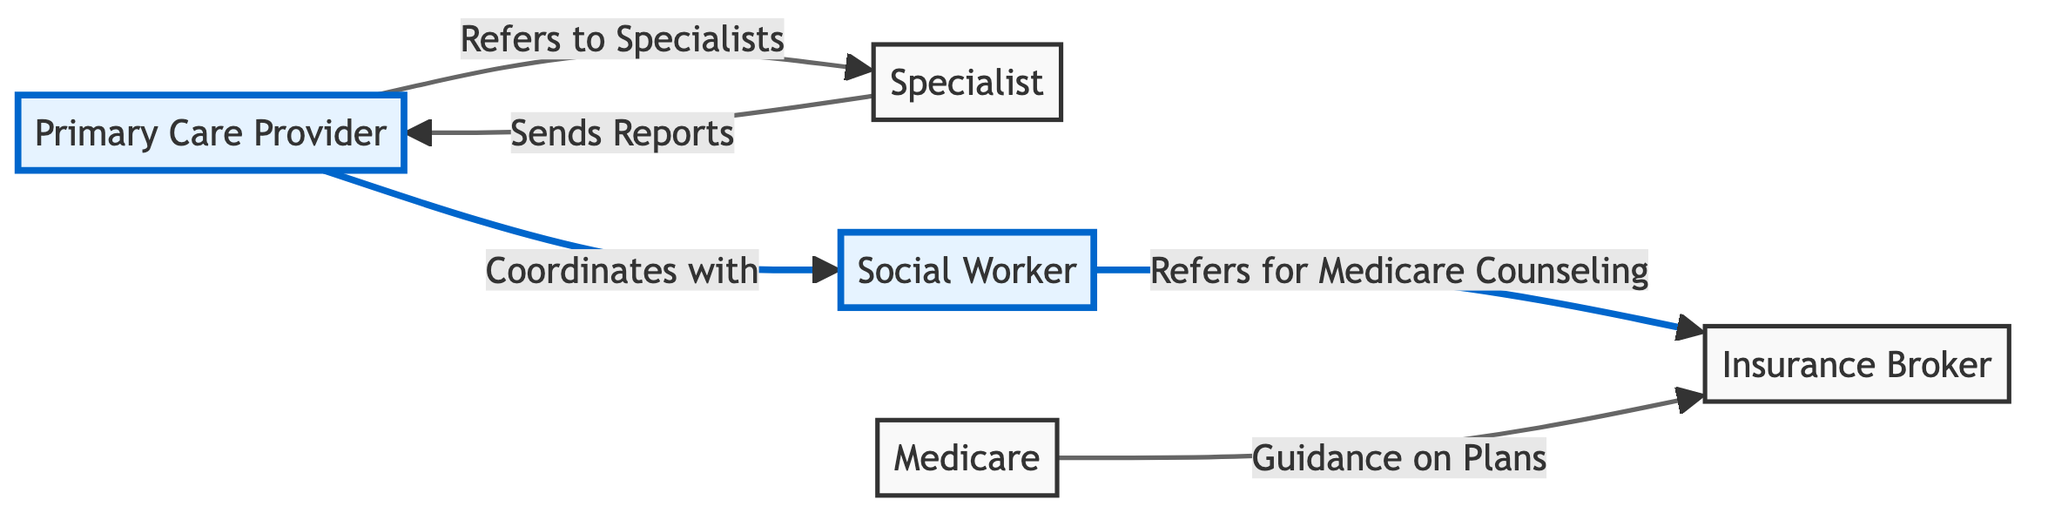What is the primary role of the Primary Care Provider? The diagram indicates that the Primary Care Provider is responsible for ensuring overall health and coordination for seniors. This includes being the main healthcare provider.
Answer: Main healthcare provider How many edges are there in the diagram? By counting the connections (arrows) between the nodes in the diagram, there are a total of five edges that illustrate the relationships among the various roles.
Answer: 5 Who does the Social Worker refer to for Medicare Counseling? The diagram shows a direct relationship where the Social Worker refers seniors to the Insurance Broker specifically for Medicare guidance.
Answer: Insurance Broker What does the Specialist send back to the Primary Care Provider? The diagram states that the Specialist sends reports to the Primary Care Provider, indicating the communication that occurs after a specialist consultation.
Answer: Reports What connection exists between the Primary Care Provider and the Specialist? The diagram shows that the Primary Care Provider refers patients to Specialists when specialized medical care is required, highlighting a crucial coordination role.
Answer: Refers to Specialists What type of counseling does the Insurance Broker provide? The diagram states that the Insurance Broker provides guidance on various Medicare plans available to seniors, which emphasizes their role in helping seniors navigate their insurance options.
Answer: Medicare plans Which two nodes are directly connected by an edge labeled "Coordinates with"? In the diagram, the edge labeled "Coordinates with" connects the Primary Care Provider and the Social Worker, indicating a collaborative relationship between these two roles.
Answer: Primary Care Provider and Social Worker What is the connection between Medicare and the Insurance Broker? The diagram illustrates that the Insurance Broker provides guidance on Medicare plans, showing a direct relationship regarding insurance counseling for seniors.
Answer: Guidance on Plans What is the function of the Social Worker within the coordination of care? The diagram illustrates that the Social Worker supports seniors by connecting them to healthcare services and referring them to insurance brokers for Medicare counseling.
Answer: Connects to healthcare services How does the Primary Care Provider ensure holistic care? The diagram demonstrates that the Primary Care Provider coordinates with the Social Worker to ensure all aspects of a senior's health care and support are addressed, which is crucial for holistic care.
Answer: Coordinates with Social Worker 